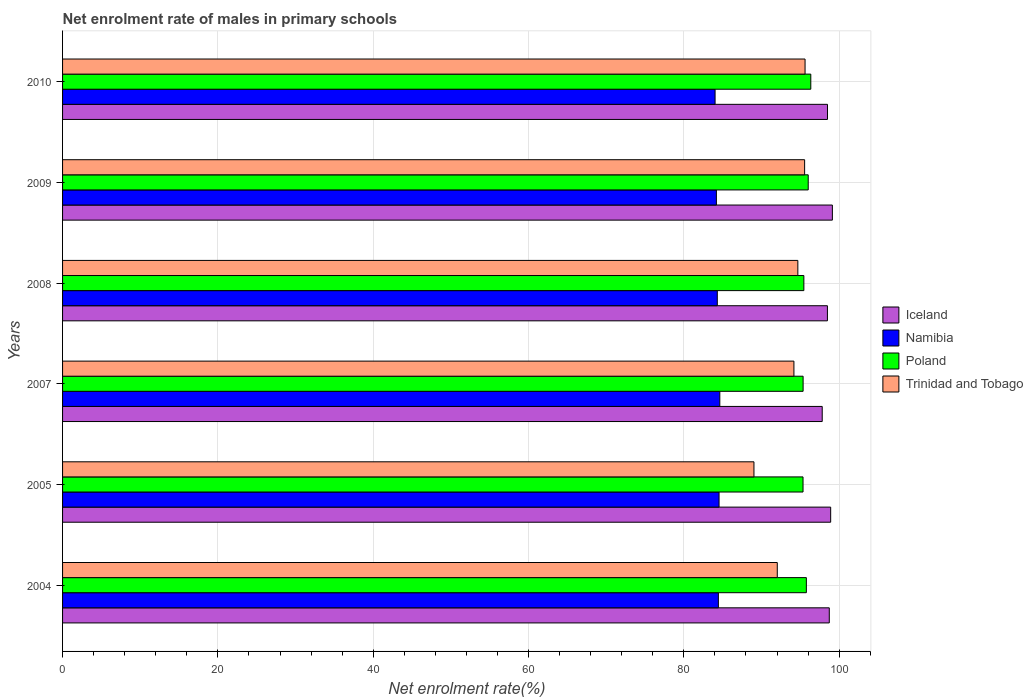How many different coloured bars are there?
Your response must be concise. 4. Are the number of bars per tick equal to the number of legend labels?
Keep it short and to the point. Yes. Are the number of bars on each tick of the Y-axis equal?
Keep it short and to the point. Yes. How many bars are there on the 5th tick from the bottom?
Provide a succinct answer. 4. What is the label of the 5th group of bars from the top?
Make the answer very short. 2005. What is the net enrolment rate of males in primary schools in Trinidad and Tobago in 2010?
Your answer should be compact. 95.61. Across all years, what is the maximum net enrolment rate of males in primary schools in Iceland?
Your answer should be very brief. 99.13. Across all years, what is the minimum net enrolment rate of males in primary schools in Namibia?
Offer a very short reply. 84.03. In which year was the net enrolment rate of males in primary schools in Poland maximum?
Your answer should be very brief. 2010. What is the total net enrolment rate of males in primary schools in Namibia in the graph?
Your response must be concise. 506.16. What is the difference between the net enrolment rate of males in primary schools in Trinidad and Tobago in 2009 and that in 2010?
Provide a short and direct response. -0.06. What is the difference between the net enrolment rate of males in primary schools in Iceland in 2009 and the net enrolment rate of males in primary schools in Trinidad and Tobago in 2008?
Offer a very short reply. 4.45. What is the average net enrolment rate of males in primary schools in Trinidad and Tobago per year?
Offer a terse response. 93.52. In the year 2010, what is the difference between the net enrolment rate of males in primary schools in Iceland and net enrolment rate of males in primary schools in Namibia?
Make the answer very short. 14.47. What is the ratio of the net enrolment rate of males in primary schools in Poland in 2005 to that in 2010?
Offer a terse response. 0.99. Is the net enrolment rate of males in primary schools in Iceland in 2004 less than that in 2010?
Your answer should be compact. No. Is the difference between the net enrolment rate of males in primary schools in Iceland in 2004 and 2007 greater than the difference between the net enrolment rate of males in primary schools in Namibia in 2004 and 2007?
Provide a short and direct response. Yes. What is the difference between the highest and the second highest net enrolment rate of males in primary schools in Iceland?
Provide a short and direct response. 0.22. What is the difference between the highest and the lowest net enrolment rate of males in primary schools in Trinidad and Tobago?
Give a very brief answer. 6.58. Is the sum of the net enrolment rate of males in primary schools in Trinidad and Tobago in 2007 and 2008 greater than the maximum net enrolment rate of males in primary schools in Namibia across all years?
Provide a succinct answer. Yes. What does the 3rd bar from the top in 2007 represents?
Your response must be concise. Namibia. What does the 2nd bar from the bottom in 2010 represents?
Your response must be concise. Namibia. Are all the bars in the graph horizontal?
Your response must be concise. Yes. How many years are there in the graph?
Offer a terse response. 6. What is the difference between two consecutive major ticks on the X-axis?
Ensure brevity in your answer.  20. Does the graph contain grids?
Provide a succinct answer. Yes. How many legend labels are there?
Your answer should be very brief. 4. What is the title of the graph?
Provide a short and direct response. Net enrolment rate of males in primary schools. Does "Virgin Islands" appear as one of the legend labels in the graph?
Give a very brief answer. No. What is the label or title of the X-axis?
Provide a succinct answer. Net enrolment rate(%). What is the Net enrolment rate(%) in Iceland in 2004?
Your answer should be very brief. 98.73. What is the Net enrolment rate(%) of Namibia in 2004?
Provide a short and direct response. 84.45. What is the Net enrolment rate(%) in Poland in 2004?
Provide a succinct answer. 95.78. What is the Net enrolment rate(%) in Trinidad and Tobago in 2004?
Keep it short and to the point. 92.04. What is the Net enrolment rate(%) of Iceland in 2005?
Offer a very short reply. 98.91. What is the Net enrolment rate(%) in Namibia in 2005?
Offer a terse response. 84.54. What is the Net enrolment rate(%) in Poland in 2005?
Keep it short and to the point. 95.35. What is the Net enrolment rate(%) in Trinidad and Tobago in 2005?
Your answer should be compact. 89.03. What is the Net enrolment rate(%) in Iceland in 2007?
Keep it short and to the point. 97.82. What is the Net enrolment rate(%) in Namibia in 2007?
Your answer should be compact. 84.64. What is the Net enrolment rate(%) in Poland in 2007?
Offer a terse response. 95.36. What is the Net enrolment rate(%) in Trinidad and Tobago in 2007?
Give a very brief answer. 94.18. What is the Net enrolment rate(%) of Iceland in 2008?
Provide a succinct answer. 98.49. What is the Net enrolment rate(%) of Namibia in 2008?
Provide a short and direct response. 84.31. What is the Net enrolment rate(%) of Poland in 2008?
Offer a very short reply. 95.46. What is the Net enrolment rate(%) of Trinidad and Tobago in 2008?
Make the answer very short. 94.68. What is the Net enrolment rate(%) in Iceland in 2009?
Offer a very short reply. 99.13. What is the Net enrolment rate(%) of Namibia in 2009?
Offer a terse response. 84.2. What is the Net enrolment rate(%) of Poland in 2009?
Your response must be concise. 96.02. What is the Net enrolment rate(%) of Trinidad and Tobago in 2009?
Ensure brevity in your answer.  95.56. What is the Net enrolment rate(%) in Iceland in 2010?
Ensure brevity in your answer.  98.5. What is the Net enrolment rate(%) in Namibia in 2010?
Make the answer very short. 84.03. What is the Net enrolment rate(%) of Poland in 2010?
Your response must be concise. 96.35. What is the Net enrolment rate(%) of Trinidad and Tobago in 2010?
Your answer should be compact. 95.61. Across all years, what is the maximum Net enrolment rate(%) in Iceland?
Offer a terse response. 99.13. Across all years, what is the maximum Net enrolment rate(%) in Namibia?
Provide a short and direct response. 84.64. Across all years, what is the maximum Net enrolment rate(%) in Poland?
Offer a very short reply. 96.35. Across all years, what is the maximum Net enrolment rate(%) in Trinidad and Tobago?
Provide a succinct answer. 95.61. Across all years, what is the minimum Net enrolment rate(%) in Iceland?
Your answer should be very brief. 97.82. Across all years, what is the minimum Net enrolment rate(%) of Namibia?
Your answer should be very brief. 84.03. Across all years, what is the minimum Net enrolment rate(%) of Poland?
Offer a terse response. 95.35. Across all years, what is the minimum Net enrolment rate(%) of Trinidad and Tobago?
Give a very brief answer. 89.03. What is the total Net enrolment rate(%) of Iceland in the graph?
Offer a very short reply. 591.59. What is the total Net enrolment rate(%) in Namibia in the graph?
Keep it short and to the point. 506.16. What is the total Net enrolment rate(%) of Poland in the graph?
Provide a short and direct response. 574.33. What is the total Net enrolment rate(%) in Trinidad and Tobago in the graph?
Keep it short and to the point. 561.11. What is the difference between the Net enrolment rate(%) in Iceland in 2004 and that in 2005?
Provide a succinct answer. -0.18. What is the difference between the Net enrolment rate(%) in Namibia in 2004 and that in 2005?
Ensure brevity in your answer.  -0.09. What is the difference between the Net enrolment rate(%) of Poland in 2004 and that in 2005?
Your response must be concise. 0.43. What is the difference between the Net enrolment rate(%) of Trinidad and Tobago in 2004 and that in 2005?
Offer a terse response. 3. What is the difference between the Net enrolment rate(%) in Iceland in 2004 and that in 2007?
Your answer should be very brief. 0.91. What is the difference between the Net enrolment rate(%) in Namibia in 2004 and that in 2007?
Offer a very short reply. -0.18. What is the difference between the Net enrolment rate(%) in Poland in 2004 and that in 2007?
Ensure brevity in your answer.  0.42. What is the difference between the Net enrolment rate(%) of Trinidad and Tobago in 2004 and that in 2007?
Make the answer very short. -2.14. What is the difference between the Net enrolment rate(%) in Iceland in 2004 and that in 2008?
Your response must be concise. 0.24. What is the difference between the Net enrolment rate(%) of Namibia in 2004 and that in 2008?
Offer a terse response. 0.14. What is the difference between the Net enrolment rate(%) in Poland in 2004 and that in 2008?
Ensure brevity in your answer.  0.32. What is the difference between the Net enrolment rate(%) of Trinidad and Tobago in 2004 and that in 2008?
Offer a terse response. -2.65. What is the difference between the Net enrolment rate(%) in Iceland in 2004 and that in 2009?
Ensure brevity in your answer.  -0.4. What is the difference between the Net enrolment rate(%) of Namibia in 2004 and that in 2009?
Your response must be concise. 0.26. What is the difference between the Net enrolment rate(%) in Poland in 2004 and that in 2009?
Provide a short and direct response. -0.24. What is the difference between the Net enrolment rate(%) of Trinidad and Tobago in 2004 and that in 2009?
Your answer should be compact. -3.52. What is the difference between the Net enrolment rate(%) of Iceland in 2004 and that in 2010?
Keep it short and to the point. 0.23. What is the difference between the Net enrolment rate(%) of Namibia in 2004 and that in 2010?
Keep it short and to the point. 0.42. What is the difference between the Net enrolment rate(%) in Poland in 2004 and that in 2010?
Ensure brevity in your answer.  -0.57. What is the difference between the Net enrolment rate(%) of Trinidad and Tobago in 2004 and that in 2010?
Ensure brevity in your answer.  -3.58. What is the difference between the Net enrolment rate(%) in Iceland in 2005 and that in 2007?
Your answer should be compact. 1.09. What is the difference between the Net enrolment rate(%) in Namibia in 2005 and that in 2007?
Ensure brevity in your answer.  -0.1. What is the difference between the Net enrolment rate(%) of Poland in 2005 and that in 2007?
Your answer should be very brief. -0.01. What is the difference between the Net enrolment rate(%) of Trinidad and Tobago in 2005 and that in 2007?
Provide a succinct answer. -5.15. What is the difference between the Net enrolment rate(%) of Iceland in 2005 and that in 2008?
Provide a short and direct response. 0.42. What is the difference between the Net enrolment rate(%) in Namibia in 2005 and that in 2008?
Offer a very short reply. 0.23. What is the difference between the Net enrolment rate(%) of Poland in 2005 and that in 2008?
Keep it short and to the point. -0.11. What is the difference between the Net enrolment rate(%) of Trinidad and Tobago in 2005 and that in 2008?
Make the answer very short. -5.65. What is the difference between the Net enrolment rate(%) in Iceland in 2005 and that in 2009?
Give a very brief answer. -0.22. What is the difference between the Net enrolment rate(%) of Namibia in 2005 and that in 2009?
Offer a very short reply. 0.34. What is the difference between the Net enrolment rate(%) in Poland in 2005 and that in 2009?
Your answer should be very brief. -0.67. What is the difference between the Net enrolment rate(%) of Trinidad and Tobago in 2005 and that in 2009?
Provide a short and direct response. -6.53. What is the difference between the Net enrolment rate(%) in Iceland in 2005 and that in 2010?
Offer a terse response. 0.41. What is the difference between the Net enrolment rate(%) in Namibia in 2005 and that in 2010?
Your answer should be very brief. 0.51. What is the difference between the Net enrolment rate(%) of Poland in 2005 and that in 2010?
Your response must be concise. -1. What is the difference between the Net enrolment rate(%) of Trinidad and Tobago in 2005 and that in 2010?
Offer a very short reply. -6.58. What is the difference between the Net enrolment rate(%) of Iceland in 2007 and that in 2008?
Keep it short and to the point. -0.67. What is the difference between the Net enrolment rate(%) in Namibia in 2007 and that in 2008?
Your response must be concise. 0.32. What is the difference between the Net enrolment rate(%) of Poland in 2007 and that in 2008?
Your response must be concise. -0.1. What is the difference between the Net enrolment rate(%) in Trinidad and Tobago in 2007 and that in 2008?
Ensure brevity in your answer.  -0.51. What is the difference between the Net enrolment rate(%) of Iceland in 2007 and that in 2009?
Give a very brief answer. -1.31. What is the difference between the Net enrolment rate(%) in Namibia in 2007 and that in 2009?
Provide a short and direct response. 0.44. What is the difference between the Net enrolment rate(%) in Poland in 2007 and that in 2009?
Offer a very short reply. -0.66. What is the difference between the Net enrolment rate(%) in Trinidad and Tobago in 2007 and that in 2009?
Ensure brevity in your answer.  -1.38. What is the difference between the Net enrolment rate(%) of Iceland in 2007 and that in 2010?
Make the answer very short. -0.68. What is the difference between the Net enrolment rate(%) of Namibia in 2007 and that in 2010?
Your response must be concise. 0.61. What is the difference between the Net enrolment rate(%) in Poland in 2007 and that in 2010?
Your response must be concise. -0.99. What is the difference between the Net enrolment rate(%) in Trinidad and Tobago in 2007 and that in 2010?
Ensure brevity in your answer.  -1.43. What is the difference between the Net enrolment rate(%) in Iceland in 2008 and that in 2009?
Provide a succinct answer. -0.64. What is the difference between the Net enrolment rate(%) in Namibia in 2008 and that in 2009?
Keep it short and to the point. 0.12. What is the difference between the Net enrolment rate(%) in Poland in 2008 and that in 2009?
Ensure brevity in your answer.  -0.56. What is the difference between the Net enrolment rate(%) in Trinidad and Tobago in 2008 and that in 2009?
Offer a very short reply. -0.87. What is the difference between the Net enrolment rate(%) in Iceland in 2008 and that in 2010?
Offer a very short reply. -0.01. What is the difference between the Net enrolment rate(%) of Namibia in 2008 and that in 2010?
Your response must be concise. 0.29. What is the difference between the Net enrolment rate(%) in Poland in 2008 and that in 2010?
Make the answer very short. -0.89. What is the difference between the Net enrolment rate(%) in Trinidad and Tobago in 2008 and that in 2010?
Make the answer very short. -0.93. What is the difference between the Net enrolment rate(%) of Iceland in 2009 and that in 2010?
Offer a terse response. 0.63. What is the difference between the Net enrolment rate(%) in Namibia in 2009 and that in 2010?
Offer a terse response. 0.17. What is the difference between the Net enrolment rate(%) in Poland in 2009 and that in 2010?
Ensure brevity in your answer.  -0.33. What is the difference between the Net enrolment rate(%) of Trinidad and Tobago in 2009 and that in 2010?
Provide a short and direct response. -0.06. What is the difference between the Net enrolment rate(%) of Iceland in 2004 and the Net enrolment rate(%) of Namibia in 2005?
Offer a terse response. 14.19. What is the difference between the Net enrolment rate(%) in Iceland in 2004 and the Net enrolment rate(%) in Poland in 2005?
Make the answer very short. 3.38. What is the difference between the Net enrolment rate(%) in Iceland in 2004 and the Net enrolment rate(%) in Trinidad and Tobago in 2005?
Your answer should be compact. 9.7. What is the difference between the Net enrolment rate(%) of Namibia in 2004 and the Net enrolment rate(%) of Poland in 2005?
Provide a succinct answer. -10.9. What is the difference between the Net enrolment rate(%) of Namibia in 2004 and the Net enrolment rate(%) of Trinidad and Tobago in 2005?
Your answer should be very brief. -4.58. What is the difference between the Net enrolment rate(%) of Poland in 2004 and the Net enrolment rate(%) of Trinidad and Tobago in 2005?
Provide a short and direct response. 6.75. What is the difference between the Net enrolment rate(%) of Iceland in 2004 and the Net enrolment rate(%) of Namibia in 2007?
Your answer should be very brief. 14.1. What is the difference between the Net enrolment rate(%) in Iceland in 2004 and the Net enrolment rate(%) in Poland in 2007?
Offer a very short reply. 3.37. What is the difference between the Net enrolment rate(%) of Iceland in 2004 and the Net enrolment rate(%) of Trinidad and Tobago in 2007?
Your answer should be compact. 4.55. What is the difference between the Net enrolment rate(%) in Namibia in 2004 and the Net enrolment rate(%) in Poland in 2007?
Provide a short and direct response. -10.91. What is the difference between the Net enrolment rate(%) in Namibia in 2004 and the Net enrolment rate(%) in Trinidad and Tobago in 2007?
Your response must be concise. -9.73. What is the difference between the Net enrolment rate(%) of Poland in 2004 and the Net enrolment rate(%) of Trinidad and Tobago in 2007?
Offer a terse response. 1.6. What is the difference between the Net enrolment rate(%) of Iceland in 2004 and the Net enrolment rate(%) of Namibia in 2008?
Keep it short and to the point. 14.42. What is the difference between the Net enrolment rate(%) in Iceland in 2004 and the Net enrolment rate(%) in Poland in 2008?
Offer a very short reply. 3.27. What is the difference between the Net enrolment rate(%) of Iceland in 2004 and the Net enrolment rate(%) of Trinidad and Tobago in 2008?
Ensure brevity in your answer.  4.05. What is the difference between the Net enrolment rate(%) of Namibia in 2004 and the Net enrolment rate(%) of Poland in 2008?
Offer a terse response. -11.01. What is the difference between the Net enrolment rate(%) in Namibia in 2004 and the Net enrolment rate(%) in Trinidad and Tobago in 2008?
Offer a terse response. -10.23. What is the difference between the Net enrolment rate(%) in Poland in 2004 and the Net enrolment rate(%) in Trinidad and Tobago in 2008?
Offer a terse response. 1.1. What is the difference between the Net enrolment rate(%) in Iceland in 2004 and the Net enrolment rate(%) in Namibia in 2009?
Your answer should be compact. 14.54. What is the difference between the Net enrolment rate(%) of Iceland in 2004 and the Net enrolment rate(%) of Poland in 2009?
Make the answer very short. 2.71. What is the difference between the Net enrolment rate(%) of Iceland in 2004 and the Net enrolment rate(%) of Trinidad and Tobago in 2009?
Your response must be concise. 3.18. What is the difference between the Net enrolment rate(%) of Namibia in 2004 and the Net enrolment rate(%) of Poland in 2009?
Give a very brief answer. -11.57. What is the difference between the Net enrolment rate(%) in Namibia in 2004 and the Net enrolment rate(%) in Trinidad and Tobago in 2009?
Make the answer very short. -11.11. What is the difference between the Net enrolment rate(%) of Poland in 2004 and the Net enrolment rate(%) of Trinidad and Tobago in 2009?
Your answer should be compact. 0.22. What is the difference between the Net enrolment rate(%) of Iceland in 2004 and the Net enrolment rate(%) of Namibia in 2010?
Provide a short and direct response. 14.71. What is the difference between the Net enrolment rate(%) of Iceland in 2004 and the Net enrolment rate(%) of Poland in 2010?
Ensure brevity in your answer.  2.38. What is the difference between the Net enrolment rate(%) of Iceland in 2004 and the Net enrolment rate(%) of Trinidad and Tobago in 2010?
Offer a terse response. 3.12. What is the difference between the Net enrolment rate(%) in Namibia in 2004 and the Net enrolment rate(%) in Poland in 2010?
Give a very brief answer. -11.9. What is the difference between the Net enrolment rate(%) in Namibia in 2004 and the Net enrolment rate(%) in Trinidad and Tobago in 2010?
Provide a succinct answer. -11.16. What is the difference between the Net enrolment rate(%) in Poland in 2004 and the Net enrolment rate(%) in Trinidad and Tobago in 2010?
Your answer should be very brief. 0.17. What is the difference between the Net enrolment rate(%) in Iceland in 2005 and the Net enrolment rate(%) in Namibia in 2007?
Keep it short and to the point. 14.28. What is the difference between the Net enrolment rate(%) of Iceland in 2005 and the Net enrolment rate(%) of Poland in 2007?
Make the answer very short. 3.55. What is the difference between the Net enrolment rate(%) of Iceland in 2005 and the Net enrolment rate(%) of Trinidad and Tobago in 2007?
Offer a terse response. 4.73. What is the difference between the Net enrolment rate(%) in Namibia in 2005 and the Net enrolment rate(%) in Poland in 2007?
Offer a terse response. -10.82. What is the difference between the Net enrolment rate(%) in Namibia in 2005 and the Net enrolment rate(%) in Trinidad and Tobago in 2007?
Your response must be concise. -9.64. What is the difference between the Net enrolment rate(%) of Poland in 2005 and the Net enrolment rate(%) of Trinidad and Tobago in 2007?
Your answer should be very brief. 1.17. What is the difference between the Net enrolment rate(%) in Iceland in 2005 and the Net enrolment rate(%) in Namibia in 2008?
Make the answer very short. 14.6. What is the difference between the Net enrolment rate(%) of Iceland in 2005 and the Net enrolment rate(%) of Poland in 2008?
Provide a short and direct response. 3.45. What is the difference between the Net enrolment rate(%) in Iceland in 2005 and the Net enrolment rate(%) in Trinidad and Tobago in 2008?
Your response must be concise. 4.23. What is the difference between the Net enrolment rate(%) of Namibia in 2005 and the Net enrolment rate(%) of Poland in 2008?
Your answer should be compact. -10.92. What is the difference between the Net enrolment rate(%) of Namibia in 2005 and the Net enrolment rate(%) of Trinidad and Tobago in 2008?
Offer a very short reply. -10.15. What is the difference between the Net enrolment rate(%) of Poland in 2005 and the Net enrolment rate(%) of Trinidad and Tobago in 2008?
Provide a short and direct response. 0.67. What is the difference between the Net enrolment rate(%) of Iceland in 2005 and the Net enrolment rate(%) of Namibia in 2009?
Make the answer very short. 14.72. What is the difference between the Net enrolment rate(%) of Iceland in 2005 and the Net enrolment rate(%) of Poland in 2009?
Ensure brevity in your answer.  2.89. What is the difference between the Net enrolment rate(%) of Iceland in 2005 and the Net enrolment rate(%) of Trinidad and Tobago in 2009?
Provide a succinct answer. 3.35. What is the difference between the Net enrolment rate(%) of Namibia in 2005 and the Net enrolment rate(%) of Poland in 2009?
Your response must be concise. -11.48. What is the difference between the Net enrolment rate(%) in Namibia in 2005 and the Net enrolment rate(%) in Trinidad and Tobago in 2009?
Offer a very short reply. -11.02. What is the difference between the Net enrolment rate(%) of Poland in 2005 and the Net enrolment rate(%) of Trinidad and Tobago in 2009?
Provide a short and direct response. -0.21. What is the difference between the Net enrolment rate(%) of Iceland in 2005 and the Net enrolment rate(%) of Namibia in 2010?
Offer a terse response. 14.88. What is the difference between the Net enrolment rate(%) of Iceland in 2005 and the Net enrolment rate(%) of Poland in 2010?
Offer a terse response. 2.56. What is the difference between the Net enrolment rate(%) in Iceland in 2005 and the Net enrolment rate(%) in Trinidad and Tobago in 2010?
Provide a short and direct response. 3.3. What is the difference between the Net enrolment rate(%) of Namibia in 2005 and the Net enrolment rate(%) of Poland in 2010?
Keep it short and to the point. -11.81. What is the difference between the Net enrolment rate(%) in Namibia in 2005 and the Net enrolment rate(%) in Trinidad and Tobago in 2010?
Ensure brevity in your answer.  -11.07. What is the difference between the Net enrolment rate(%) in Poland in 2005 and the Net enrolment rate(%) in Trinidad and Tobago in 2010?
Keep it short and to the point. -0.26. What is the difference between the Net enrolment rate(%) of Iceland in 2007 and the Net enrolment rate(%) of Namibia in 2008?
Provide a short and direct response. 13.51. What is the difference between the Net enrolment rate(%) of Iceland in 2007 and the Net enrolment rate(%) of Poland in 2008?
Your response must be concise. 2.36. What is the difference between the Net enrolment rate(%) in Iceland in 2007 and the Net enrolment rate(%) in Trinidad and Tobago in 2008?
Keep it short and to the point. 3.14. What is the difference between the Net enrolment rate(%) in Namibia in 2007 and the Net enrolment rate(%) in Poland in 2008?
Offer a terse response. -10.82. What is the difference between the Net enrolment rate(%) in Namibia in 2007 and the Net enrolment rate(%) in Trinidad and Tobago in 2008?
Provide a short and direct response. -10.05. What is the difference between the Net enrolment rate(%) of Poland in 2007 and the Net enrolment rate(%) of Trinidad and Tobago in 2008?
Provide a succinct answer. 0.68. What is the difference between the Net enrolment rate(%) of Iceland in 2007 and the Net enrolment rate(%) of Namibia in 2009?
Make the answer very short. 13.63. What is the difference between the Net enrolment rate(%) in Iceland in 2007 and the Net enrolment rate(%) in Poland in 2009?
Your answer should be very brief. 1.8. What is the difference between the Net enrolment rate(%) in Iceland in 2007 and the Net enrolment rate(%) in Trinidad and Tobago in 2009?
Your response must be concise. 2.26. What is the difference between the Net enrolment rate(%) in Namibia in 2007 and the Net enrolment rate(%) in Poland in 2009?
Provide a succinct answer. -11.38. What is the difference between the Net enrolment rate(%) of Namibia in 2007 and the Net enrolment rate(%) of Trinidad and Tobago in 2009?
Provide a succinct answer. -10.92. What is the difference between the Net enrolment rate(%) of Poland in 2007 and the Net enrolment rate(%) of Trinidad and Tobago in 2009?
Your answer should be very brief. -0.2. What is the difference between the Net enrolment rate(%) of Iceland in 2007 and the Net enrolment rate(%) of Namibia in 2010?
Provide a short and direct response. 13.8. What is the difference between the Net enrolment rate(%) in Iceland in 2007 and the Net enrolment rate(%) in Poland in 2010?
Offer a terse response. 1.47. What is the difference between the Net enrolment rate(%) in Iceland in 2007 and the Net enrolment rate(%) in Trinidad and Tobago in 2010?
Give a very brief answer. 2.21. What is the difference between the Net enrolment rate(%) of Namibia in 2007 and the Net enrolment rate(%) of Poland in 2010?
Give a very brief answer. -11.72. What is the difference between the Net enrolment rate(%) of Namibia in 2007 and the Net enrolment rate(%) of Trinidad and Tobago in 2010?
Keep it short and to the point. -10.98. What is the difference between the Net enrolment rate(%) in Poland in 2007 and the Net enrolment rate(%) in Trinidad and Tobago in 2010?
Provide a short and direct response. -0.25. What is the difference between the Net enrolment rate(%) of Iceland in 2008 and the Net enrolment rate(%) of Namibia in 2009?
Your answer should be very brief. 14.3. What is the difference between the Net enrolment rate(%) of Iceland in 2008 and the Net enrolment rate(%) of Poland in 2009?
Your answer should be very brief. 2.47. What is the difference between the Net enrolment rate(%) of Iceland in 2008 and the Net enrolment rate(%) of Trinidad and Tobago in 2009?
Your answer should be compact. 2.93. What is the difference between the Net enrolment rate(%) of Namibia in 2008 and the Net enrolment rate(%) of Poland in 2009?
Your response must be concise. -11.71. What is the difference between the Net enrolment rate(%) of Namibia in 2008 and the Net enrolment rate(%) of Trinidad and Tobago in 2009?
Offer a terse response. -11.25. What is the difference between the Net enrolment rate(%) in Poland in 2008 and the Net enrolment rate(%) in Trinidad and Tobago in 2009?
Provide a succinct answer. -0.1. What is the difference between the Net enrolment rate(%) in Iceland in 2008 and the Net enrolment rate(%) in Namibia in 2010?
Offer a very short reply. 14.47. What is the difference between the Net enrolment rate(%) in Iceland in 2008 and the Net enrolment rate(%) in Poland in 2010?
Ensure brevity in your answer.  2.14. What is the difference between the Net enrolment rate(%) in Iceland in 2008 and the Net enrolment rate(%) in Trinidad and Tobago in 2010?
Give a very brief answer. 2.88. What is the difference between the Net enrolment rate(%) in Namibia in 2008 and the Net enrolment rate(%) in Poland in 2010?
Provide a short and direct response. -12.04. What is the difference between the Net enrolment rate(%) of Namibia in 2008 and the Net enrolment rate(%) of Trinidad and Tobago in 2010?
Offer a terse response. -11.3. What is the difference between the Net enrolment rate(%) in Poland in 2008 and the Net enrolment rate(%) in Trinidad and Tobago in 2010?
Your response must be concise. -0.15. What is the difference between the Net enrolment rate(%) in Iceland in 2009 and the Net enrolment rate(%) in Namibia in 2010?
Offer a very short reply. 15.1. What is the difference between the Net enrolment rate(%) of Iceland in 2009 and the Net enrolment rate(%) of Poland in 2010?
Provide a succinct answer. 2.78. What is the difference between the Net enrolment rate(%) in Iceland in 2009 and the Net enrolment rate(%) in Trinidad and Tobago in 2010?
Provide a succinct answer. 3.52. What is the difference between the Net enrolment rate(%) in Namibia in 2009 and the Net enrolment rate(%) in Poland in 2010?
Keep it short and to the point. -12.16. What is the difference between the Net enrolment rate(%) of Namibia in 2009 and the Net enrolment rate(%) of Trinidad and Tobago in 2010?
Offer a terse response. -11.42. What is the difference between the Net enrolment rate(%) of Poland in 2009 and the Net enrolment rate(%) of Trinidad and Tobago in 2010?
Your response must be concise. 0.41. What is the average Net enrolment rate(%) in Iceland per year?
Keep it short and to the point. 98.6. What is the average Net enrolment rate(%) of Namibia per year?
Your answer should be compact. 84.36. What is the average Net enrolment rate(%) in Poland per year?
Ensure brevity in your answer.  95.72. What is the average Net enrolment rate(%) in Trinidad and Tobago per year?
Give a very brief answer. 93.52. In the year 2004, what is the difference between the Net enrolment rate(%) of Iceland and Net enrolment rate(%) of Namibia?
Your answer should be compact. 14.28. In the year 2004, what is the difference between the Net enrolment rate(%) in Iceland and Net enrolment rate(%) in Poland?
Your answer should be very brief. 2.95. In the year 2004, what is the difference between the Net enrolment rate(%) of Iceland and Net enrolment rate(%) of Trinidad and Tobago?
Give a very brief answer. 6.7. In the year 2004, what is the difference between the Net enrolment rate(%) of Namibia and Net enrolment rate(%) of Poland?
Keep it short and to the point. -11.33. In the year 2004, what is the difference between the Net enrolment rate(%) in Namibia and Net enrolment rate(%) in Trinidad and Tobago?
Offer a very short reply. -7.59. In the year 2004, what is the difference between the Net enrolment rate(%) in Poland and Net enrolment rate(%) in Trinidad and Tobago?
Your response must be concise. 3.74. In the year 2005, what is the difference between the Net enrolment rate(%) of Iceland and Net enrolment rate(%) of Namibia?
Make the answer very short. 14.37. In the year 2005, what is the difference between the Net enrolment rate(%) of Iceland and Net enrolment rate(%) of Poland?
Keep it short and to the point. 3.56. In the year 2005, what is the difference between the Net enrolment rate(%) of Iceland and Net enrolment rate(%) of Trinidad and Tobago?
Your response must be concise. 9.88. In the year 2005, what is the difference between the Net enrolment rate(%) of Namibia and Net enrolment rate(%) of Poland?
Your answer should be compact. -10.81. In the year 2005, what is the difference between the Net enrolment rate(%) of Namibia and Net enrolment rate(%) of Trinidad and Tobago?
Ensure brevity in your answer.  -4.49. In the year 2005, what is the difference between the Net enrolment rate(%) in Poland and Net enrolment rate(%) in Trinidad and Tobago?
Keep it short and to the point. 6.32. In the year 2007, what is the difference between the Net enrolment rate(%) in Iceland and Net enrolment rate(%) in Namibia?
Offer a terse response. 13.19. In the year 2007, what is the difference between the Net enrolment rate(%) in Iceland and Net enrolment rate(%) in Poland?
Your response must be concise. 2.46. In the year 2007, what is the difference between the Net enrolment rate(%) of Iceland and Net enrolment rate(%) of Trinidad and Tobago?
Your answer should be very brief. 3.64. In the year 2007, what is the difference between the Net enrolment rate(%) of Namibia and Net enrolment rate(%) of Poland?
Ensure brevity in your answer.  -10.73. In the year 2007, what is the difference between the Net enrolment rate(%) in Namibia and Net enrolment rate(%) in Trinidad and Tobago?
Your response must be concise. -9.54. In the year 2007, what is the difference between the Net enrolment rate(%) of Poland and Net enrolment rate(%) of Trinidad and Tobago?
Provide a succinct answer. 1.18. In the year 2008, what is the difference between the Net enrolment rate(%) of Iceland and Net enrolment rate(%) of Namibia?
Keep it short and to the point. 14.18. In the year 2008, what is the difference between the Net enrolment rate(%) in Iceland and Net enrolment rate(%) in Poland?
Your response must be concise. 3.03. In the year 2008, what is the difference between the Net enrolment rate(%) of Iceland and Net enrolment rate(%) of Trinidad and Tobago?
Ensure brevity in your answer.  3.81. In the year 2008, what is the difference between the Net enrolment rate(%) in Namibia and Net enrolment rate(%) in Poland?
Offer a very short reply. -11.15. In the year 2008, what is the difference between the Net enrolment rate(%) in Namibia and Net enrolment rate(%) in Trinidad and Tobago?
Give a very brief answer. -10.37. In the year 2008, what is the difference between the Net enrolment rate(%) of Poland and Net enrolment rate(%) of Trinidad and Tobago?
Your answer should be very brief. 0.78. In the year 2009, what is the difference between the Net enrolment rate(%) in Iceland and Net enrolment rate(%) in Namibia?
Your answer should be compact. 14.94. In the year 2009, what is the difference between the Net enrolment rate(%) of Iceland and Net enrolment rate(%) of Poland?
Ensure brevity in your answer.  3.11. In the year 2009, what is the difference between the Net enrolment rate(%) in Iceland and Net enrolment rate(%) in Trinidad and Tobago?
Keep it short and to the point. 3.57. In the year 2009, what is the difference between the Net enrolment rate(%) in Namibia and Net enrolment rate(%) in Poland?
Give a very brief answer. -11.82. In the year 2009, what is the difference between the Net enrolment rate(%) of Namibia and Net enrolment rate(%) of Trinidad and Tobago?
Give a very brief answer. -11.36. In the year 2009, what is the difference between the Net enrolment rate(%) of Poland and Net enrolment rate(%) of Trinidad and Tobago?
Offer a very short reply. 0.46. In the year 2010, what is the difference between the Net enrolment rate(%) in Iceland and Net enrolment rate(%) in Namibia?
Offer a very short reply. 14.47. In the year 2010, what is the difference between the Net enrolment rate(%) in Iceland and Net enrolment rate(%) in Poland?
Your answer should be compact. 2.15. In the year 2010, what is the difference between the Net enrolment rate(%) of Iceland and Net enrolment rate(%) of Trinidad and Tobago?
Your response must be concise. 2.89. In the year 2010, what is the difference between the Net enrolment rate(%) in Namibia and Net enrolment rate(%) in Poland?
Provide a succinct answer. -12.32. In the year 2010, what is the difference between the Net enrolment rate(%) in Namibia and Net enrolment rate(%) in Trinidad and Tobago?
Provide a short and direct response. -11.59. In the year 2010, what is the difference between the Net enrolment rate(%) in Poland and Net enrolment rate(%) in Trinidad and Tobago?
Your answer should be very brief. 0.74. What is the ratio of the Net enrolment rate(%) of Poland in 2004 to that in 2005?
Give a very brief answer. 1. What is the ratio of the Net enrolment rate(%) of Trinidad and Tobago in 2004 to that in 2005?
Make the answer very short. 1.03. What is the ratio of the Net enrolment rate(%) in Iceland in 2004 to that in 2007?
Ensure brevity in your answer.  1.01. What is the ratio of the Net enrolment rate(%) of Namibia in 2004 to that in 2007?
Offer a very short reply. 1. What is the ratio of the Net enrolment rate(%) of Poland in 2004 to that in 2007?
Make the answer very short. 1. What is the ratio of the Net enrolment rate(%) in Trinidad and Tobago in 2004 to that in 2007?
Your response must be concise. 0.98. What is the ratio of the Net enrolment rate(%) of Iceland in 2004 to that in 2008?
Offer a very short reply. 1. What is the ratio of the Net enrolment rate(%) of Iceland in 2004 to that in 2009?
Provide a succinct answer. 1. What is the ratio of the Net enrolment rate(%) of Trinidad and Tobago in 2004 to that in 2009?
Make the answer very short. 0.96. What is the ratio of the Net enrolment rate(%) of Trinidad and Tobago in 2004 to that in 2010?
Make the answer very short. 0.96. What is the ratio of the Net enrolment rate(%) of Iceland in 2005 to that in 2007?
Offer a very short reply. 1.01. What is the ratio of the Net enrolment rate(%) of Poland in 2005 to that in 2007?
Your answer should be very brief. 1. What is the ratio of the Net enrolment rate(%) of Trinidad and Tobago in 2005 to that in 2007?
Your answer should be compact. 0.95. What is the ratio of the Net enrolment rate(%) of Iceland in 2005 to that in 2008?
Offer a very short reply. 1. What is the ratio of the Net enrolment rate(%) in Namibia in 2005 to that in 2008?
Your answer should be very brief. 1. What is the ratio of the Net enrolment rate(%) in Trinidad and Tobago in 2005 to that in 2008?
Provide a succinct answer. 0.94. What is the ratio of the Net enrolment rate(%) of Namibia in 2005 to that in 2009?
Keep it short and to the point. 1. What is the ratio of the Net enrolment rate(%) in Poland in 2005 to that in 2009?
Provide a succinct answer. 0.99. What is the ratio of the Net enrolment rate(%) in Trinidad and Tobago in 2005 to that in 2009?
Your response must be concise. 0.93. What is the ratio of the Net enrolment rate(%) in Iceland in 2005 to that in 2010?
Your answer should be compact. 1. What is the ratio of the Net enrolment rate(%) of Namibia in 2005 to that in 2010?
Provide a succinct answer. 1.01. What is the ratio of the Net enrolment rate(%) of Trinidad and Tobago in 2005 to that in 2010?
Give a very brief answer. 0.93. What is the ratio of the Net enrolment rate(%) of Iceland in 2007 to that in 2008?
Give a very brief answer. 0.99. What is the ratio of the Net enrolment rate(%) in Namibia in 2007 to that in 2008?
Provide a short and direct response. 1. What is the ratio of the Net enrolment rate(%) of Namibia in 2007 to that in 2009?
Keep it short and to the point. 1.01. What is the ratio of the Net enrolment rate(%) in Poland in 2007 to that in 2009?
Give a very brief answer. 0.99. What is the ratio of the Net enrolment rate(%) of Trinidad and Tobago in 2007 to that in 2009?
Offer a terse response. 0.99. What is the ratio of the Net enrolment rate(%) in Iceland in 2007 to that in 2010?
Ensure brevity in your answer.  0.99. What is the ratio of the Net enrolment rate(%) of Poland in 2007 to that in 2010?
Offer a terse response. 0.99. What is the ratio of the Net enrolment rate(%) of Trinidad and Tobago in 2008 to that in 2009?
Give a very brief answer. 0.99. What is the ratio of the Net enrolment rate(%) of Iceland in 2008 to that in 2010?
Keep it short and to the point. 1. What is the ratio of the Net enrolment rate(%) of Namibia in 2008 to that in 2010?
Keep it short and to the point. 1. What is the ratio of the Net enrolment rate(%) of Poland in 2008 to that in 2010?
Your answer should be very brief. 0.99. What is the ratio of the Net enrolment rate(%) in Trinidad and Tobago in 2008 to that in 2010?
Keep it short and to the point. 0.99. What is the ratio of the Net enrolment rate(%) of Iceland in 2009 to that in 2010?
Provide a succinct answer. 1.01. What is the ratio of the Net enrolment rate(%) of Trinidad and Tobago in 2009 to that in 2010?
Offer a terse response. 1. What is the difference between the highest and the second highest Net enrolment rate(%) in Iceland?
Offer a terse response. 0.22. What is the difference between the highest and the second highest Net enrolment rate(%) of Namibia?
Keep it short and to the point. 0.1. What is the difference between the highest and the second highest Net enrolment rate(%) in Poland?
Provide a succinct answer. 0.33. What is the difference between the highest and the second highest Net enrolment rate(%) in Trinidad and Tobago?
Ensure brevity in your answer.  0.06. What is the difference between the highest and the lowest Net enrolment rate(%) in Iceland?
Keep it short and to the point. 1.31. What is the difference between the highest and the lowest Net enrolment rate(%) of Namibia?
Ensure brevity in your answer.  0.61. What is the difference between the highest and the lowest Net enrolment rate(%) of Trinidad and Tobago?
Offer a very short reply. 6.58. 